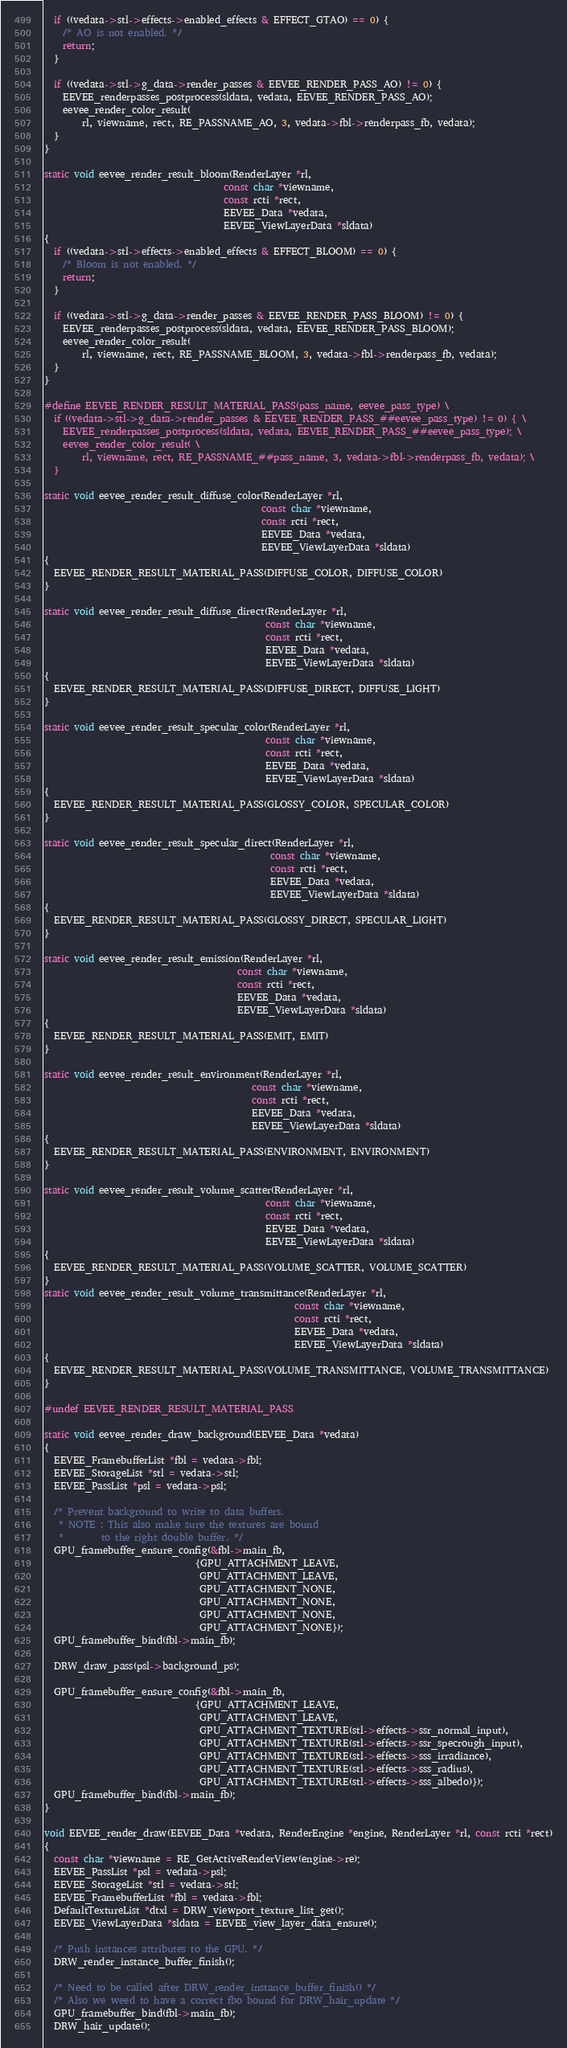Convert code to text. <code><loc_0><loc_0><loc_500><loc_500><_C_>  if ((vedata->stl->effects->enabled_effects & EFFECT_GTAO) == 0) {
    /* AO is not enabled. */
    return;
  }

  if ((vedata->stl->g_data->render_passes & EEVEE_RENDER_PASS_AO) != 0) {
    EEVEE_renderpasses_postprocess(sldata, vedata, EEVEE_RENDER_PASS_AO);
    eevee_render_color_result(
        rl, viewname, rect, RE_PASSNAME_AO, 3, vedata->fbl->renderpass_fb, vedata);
  }
}

static void eevee_render_result_bloom(RenderLayer *rl,
                                      const char *viewname,
                                      const rcti *rect,
                                      EEVEE_Data *vedata,
                                      EEVEE_ViewLayerData *sldata)
{
  if ((vedata->stl->effects->enabled_effects & EFFECT_BLOOM) == 0) {
    /* Bloom is not enabled. */
    return;
  }

  if ((vedata->stl->g_data->render_passes & EEVEE_RENDER_PASS_BLOOM) != 0) {
    EEVEE_renderpasses_postprocess(sldata, vedata, EEVEE_RENDER_PASS_BLOOM);
    eevee_render_color_result(
        rl, viewname, rect, RE_PASSNAME_BLOOM, 3, vedata->fbl->renderpass_fb, vedata);
  }
}

#define EEVEE_RENDER_RESULT_MATERIAL_PASS(pass_name, eevee_pass_type) \
  if ((vedata->stl->g_data->render_passes & EEVEE_RENDER_PASS_##eevee_pass_type) != 0) { \
    EEVEE_renderpasses_postprocess(sldata, vedata, EEVEE_RENDER_PASS_##eevee_pass_type); \
    eevee_render_color_result( \
        rl, viewname, rect, RE_PASSNAME_##pass_name, 3, vedata->fbl->renderpass_fb, vedata); \
  }

static void eevee_render_result_diffuse_color(RenderLayer *rl,
                                              const char *viewname,
                                              const rcti *rect,
                                              EEVEE_Data *vedata,
                                              EEVEE_ViewLayerData *sldata)
{
  EEVEE_RENDER_RESULT_MATERIAL_PASS(DIFFUSE_COLOR, DIFFUSE_COLOR)
}

static void eevee_render_result_diffuse_direct(RenderLayer *rl,
                                               const char *viewname,
                                               const rcti *rect,
                                               EEVEE_Data *vedata,
                                               EEVEE_ViewLayerData *sldata)
{
  EEVEE_RENDER_RESULT_MATERIAL_PASS(DIFFUSE_DIRECT, DIFFUSE_LIGHT)
}

static void eevee_render_result_specular_color(RenderLayer *rl,
                                               const char *viewname,
                                               const rcti *rect,
                                               EEVEE_Data *vedata,
                                               EEVEE_ViewLayerData *sldata)
{
  EEVEE_RENDER_RESULT_MATERIAL_PASS(GLOSSY_COLOR, SPECULAR_COLOR)
}

static void eevee_render_result_specular_direct(RenderLayer *rl,
                                                const char *viewname,
                                                const rcti *rect,
                                                EEVEE_Data *vedata,
                                                EEVEE_ViewLayerData *sldata)
{
  EEVEE_RENDER_RESULT_MATERIAL_PASS(GLOSSY_DIRECT, SPECULAR_LIGHT)
}

static void eevee_render_result_emission(RenderLayer *rl,
                                         const char *viewname,
                                         const rcti *rect,
                                         EEVEE_Data *vedata,
                                         EEVEE_ViewLayerData *sldata)
{
  EEVEE_RENDER_RESULT_MATERIAL_PASS(EMIT, EMIT)
}

static void eevee_render_result_environment(RenderLayer *rl,
                                            const char *viewname,
                                            const rcti *rect,
                                            EEVEE_Data *vedata,
                                            EEVEE_ViewLayerData *sldata)
{
  EEVEE_RENDER_RESULT_MATERIAL_PASS(ENVIRONMENT, ENVIRONMENT)
}

static void eevee_render_result_volume_scatter(RenderLayer *rl,
                                               const char *viewname,
                                               const rcti *rect,
                                               EEVEE_Data *vedata,
                                               EEVEE_ViewLayerData *sldata)
{
  EEVEE_RENDER_RESULT_MATERIAL_PASS(VOLUME_SCATTER, VOLUME_SCATTER)
}
static void eevee_render_result_volume_transmittance(RenderLayer *rl,
                                                     const char *viewname,
                                                     const rcti *rect,
                                                     EEVEE_Data *vedata,
                                                     EEVEE_ViewLayerData *sldata)
{
  EEVEE_RENDER_RESULT_MATERIAL_PASS(VOLUME_TRANSMITTANCE, VOLUME_TRANSMITTANCE)
}

#undef EEVEE_RENDER_RESULT_MATERIAL_PASS

static void eevee_render_draw_background(EEVEE_Data *vedata)
{
  EEVEE_FramebufferList *fbl = vedata->fbl;
  EEVEE_StorageList *stl = vedata->stl;
  EEVEE_PassList *psl = vedata->psl;

  /* Prevent background to write to data buffers.
   * NOTE : This also make sure the textures are bound
   *        to the right double buffer. */
  GPU_framebuffer_ensure_config(&fbl->main_fb,
                                {GPU_ATTACHMENT_LEAVE,
                                 GPU_ATTACHMENT_LEAVE,
                                 GPU_ATTACHMENT_NONE,
                                 GPU_ATTACHMENT_NONE,
                                 GPU_ATTACHMENT_NONE,
                                 GPU_ATTACHMENT_NONE});
  GPU_framebuffer_bind(fbl->main_fb);

  DRW_draw_pass(psl->background_ps);

  GPU_framebuffer_ensure_config(&fbl->main_fb,
                                {GPU_ATTACHMENT_LEAVE,
                                 GPU_ATTACHMENT_LEAVE,
                                 GPU_ATTACHMENT_TEXTURE(stl->effects->ssr_normal_input),
                                 GPU_ATTACHMENT_TEXTURE(stl->effects->ssr_specrough_input),
                                 GPU_ATTACHMENT_TEXTURE(stl->effects->sss_irradiance),
                                 GPU_ATTACHMENT_TEXTURE(stl->effects->sss_radius),
                                 GPU_ATTACHMENT_TEXTURE(stl->effects->sss_albedo)});
  GPU_framebuffer_bind(fbl->main_fb);
}

void EEVEE_render_draw(EEVEE_Data *vedata, RenderEngine *engine, RenderLayer *rl, const rcti *rect)
{
  const char *viewname = RE_GetActiveRenderView(engine->re);
  EEVEE_PassList *psl = vedata->psl;
  EEVEE_StorageList *stl = vedata->stl;
  EEVEE_FramebufferList *fbl = vedata->fbl;
  DefaultTextureList *dtxl = DRW_viewport_texture_list_get();
  EEVEE_ViewLayerData *sldata = EEVEE_view_layer_data_ensure();

  /* Push instances attributes to the GPU. */
  DRW_render_instance_buffer_finish();

  /* Need to be called after DRW_render_instance_buffer_finish() */
  /* Also we weed to have a correct fbo bound for DRW_hair_update */
  GPU_framebuffer_bind(fbl->main_fb);
  DRW_hair_update();
</code> 